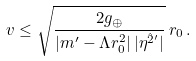<formula> <loc_0><loc_0><loc_500><loc_500>v \leq \sqrt { \frac { 2 g _ { \oplus } } { | m ^ { \prime } - \Lambda r _ { 0 } ^ { 2 } | \, | \eta ^ { \hat { 2 } ^ { \prime } } | } } \, r _ { 0 } \, .</formula> 